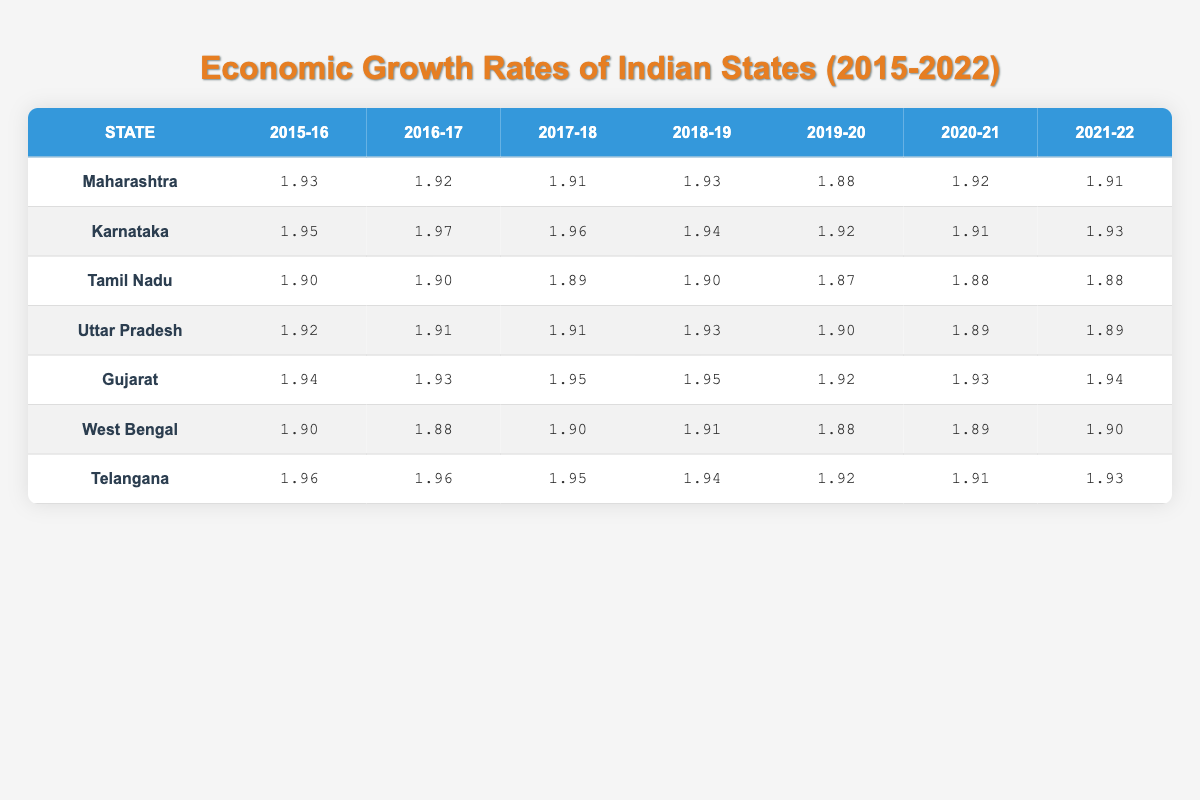What was the highest economic growth rate recorded for Karnataka in the given years? The growth rates for Karnataka are: 7.9, 8.5, 8.2, 7.6, 6.7, 6.5, and 7.3. The highest value in this list is 8.5, recorded in the year 2016-17.
Answer: 8.5 Which state had the lowest economic growth rate in 2019-20? The growth rates for each state in 2019-20 are: Maharashtra (5.8), Karnataka (6.7), Tamil Nadu (5.5), Uttar Pradesh (6.2), Gujarat (6.9), West Bengal (5.7), and Telangana (6.8). Among these, Tamil Nadu has the lowest value at 5.5.
Answer: Tamil Nadu Was the economic growth rate of Uttar Pradesh consistently above 6 from 2015-2022? Checking the growth rates for Uttar Pradesh: 6.7, 6.5, 6.4, 7.1, 6.2, 5.9, 6.0. The values 5.9 and 6.0 are below 6 in the years 2020-21 and 2021-22, respectively. Hence, the answer is no.
Answer: No What is the average economic growth rate for Maharashtra from 2015 to 2022? The growth rates for Maharashtra are: 7.1, 6.8, 6.5, 7.0, 5.8, 6.9, 6.4. We sum these values: 7.1 + 6.8 + 6.5 + 7.0 + 5.8 + 6.9 + 6.4 = 47.5. Then divide by 7 to find the average: 47.5 / 7 = 6.79.
Answer: 6.79 Which state showed the most consistent growth over the years? To find consistency, we look for the smallest range between the highest and lowest growth rates. Calculating for each state: Maharashtra (1.3), Karnataka (1.4), Tamil Nadu (0.8), Uttar Pradesh (1.2), Gujarat (1.2), West Bengal (0.5), Telangana (0.6). West Bengal, with a range of 0.5 (0.76 to 0.81) indicates the most consistent growth.
Answer: West Bengal In which year did Maharashtra have its highest growth rate? Referring to the growth rates of Maharashtra: 7.1, 6.8, 6.5, 7.0, 5.8, 6.9, 6.4, we see the highest value is 7.1 in the year 2015-16.
Answer: 2015-16 Did Gujarat's growth rate exceed 8 at any point between 2015-2022? The growth rates for Gujarat are: 7.5, 7.2, 8.0, 7.8, 6.9, 7.1, 7.4. The highest value is 8.0 in 2017-18, which exceeds 8.
Answer: Yes What was the median economic growth rate for Telangana during the period? The growth rates for Telangana are: 8.1, 8.3, 7.9, 7.4, 6.8, 6.6, 7.2. When sorting the values, we get: 6.6, 6.8, 7.2, 7.4, 7.9, 8.1, 8.3. The median is the middle value, which is 7.4.
Answer: 7.4 